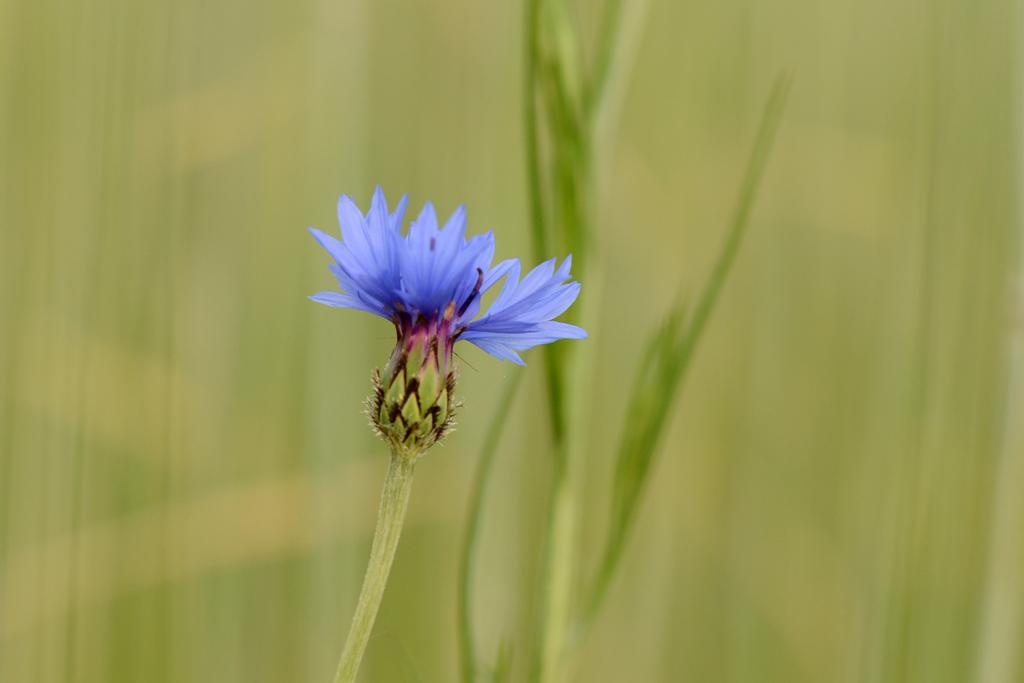How would you summarize this image in a sentence or two? In this picture we can see a flower and plants. Background is blurry. 